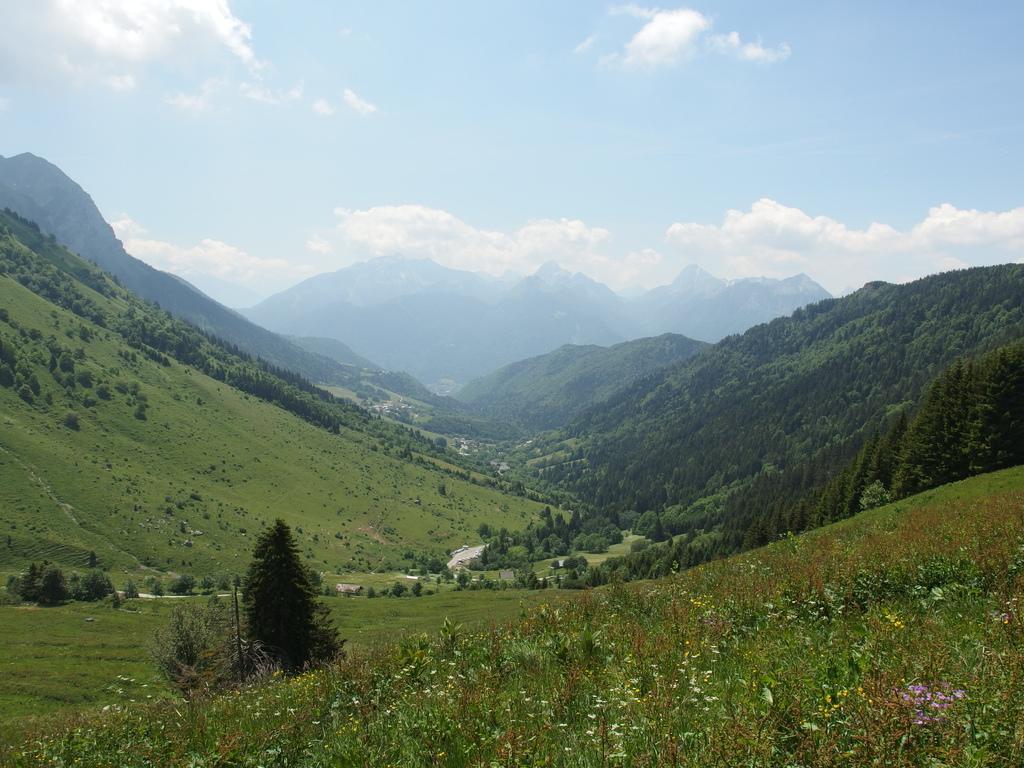In one or two sentences, can you explain what this image depicts? In this image there are trees, mountains and a cloudy sky. 